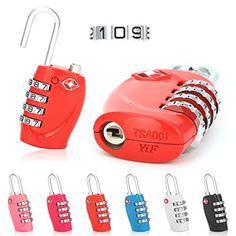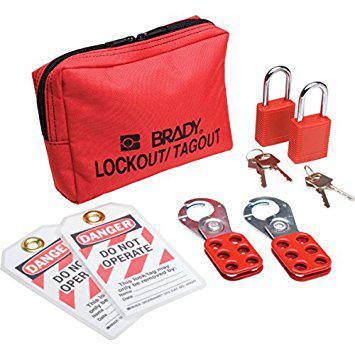The first image is the image on the left, the second image is the image on the right. For the images displayed, is the sentence "At least two of the locks are combination locks." factually correct? Answer yes or no. Yes. 